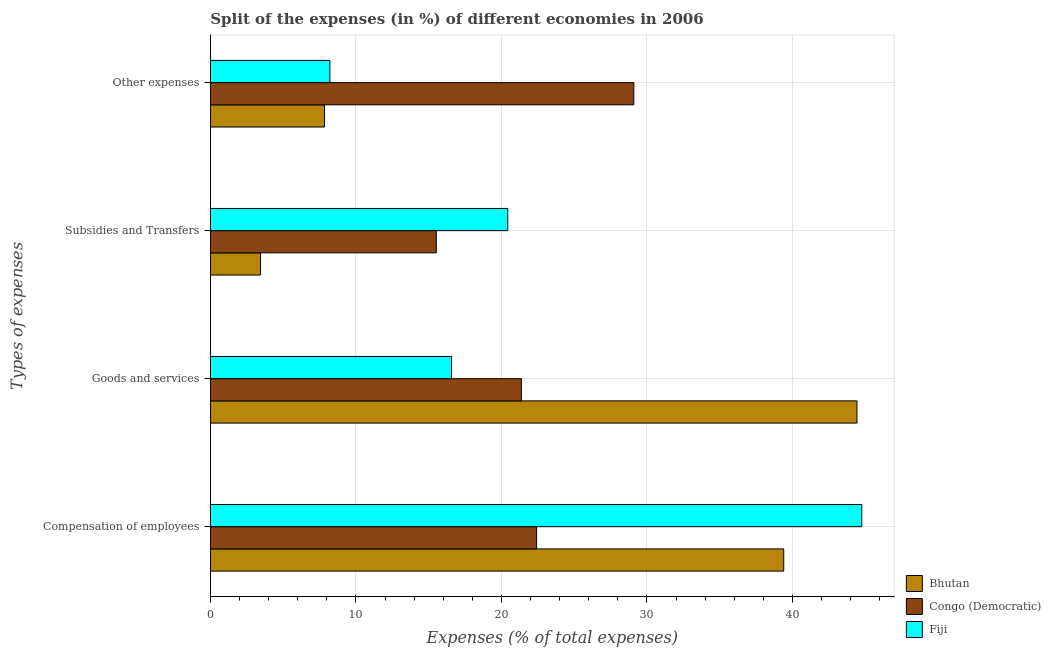Are the number of bars per tick equal to the number of legend labels?
Give a very brief answer. Yes. Are the number of bars on each tick of the Y-axis equal?
Provide a short and direct response. Yes. How many bars are there on the 1st tick from the bottom?
Your answer should be very brief. 3. What is the label of the 3rd group of bars from the top?
Your answer should be very brief. Goods and services. What is the percentage of amount spent on subsidies in Congo (Democratic)?
Provide a succinct answer. 15.53. Across all countries, what is the maximum percentage of amount spent on other expenses?
Give a very brief answer. 29.1. Across all countries, what is the minimum percentage of amount spent on goods and services?
Your answer should be very brief. 16.57. In which country was the percentage of amount spent on compensation of employees maximum?
Make the answer very short. Fiji. In which country was the percentage of amount spent on goods and services minimum?
Provide a short and direct response. Fiji. What is the total percentage of amount spent on compensation of employees in the graph?
Keep it short and to the point. 106.59. What is the difference between the percentage of amount spent on goods and services in Bhutan and that in Fiji?
Your answer should be very brief. 27.86. What is the difference between the percentage of amount spent on other expenses in Fiji and the percentage of amount spent on compensation of employees in Congo (Democratic)?
Keep it short and to the point. -14.21. What is the average percentage of amount spent on compensation of employees per country?
Offer a terse response. 35.53. What is the difference between the percentage of amount spent on compensation of employees and percentage of amount spent on goods and services in Fiji?
Your answer should be compact. 28.19. What is the ratio of the percentage of amount spent on other expenses in Bhutan to that in Congo (Democratic)?
Give a very brief answer. 0.27. What is the difference between the highest and the second highest percentage of amount spent on compensation of employees?
Your response must be concise. 5.36. What is the difference between the highest and the lowest percentage of amount spent on goods and services?
Make the answer very short. 27.86. Is the sum of the percentage of amount spent on other expenses in Bhutan and Congo (Democratic) greater than the maximum percentage of amount spent on subsidies across all countries?
Provide a succinct answer. Yes. Is it the case that in every country, the sum of the percentage of amount spent on goods and services and percentage of amount spent on subsidies is greater than the sum of percentage of amount spent on other expenses and percentage of amount spent on compensation of employees?
Your response must be concise. No. What does the 1st bar from the top in Compensation of employees represents?
Provide a succinct answer. Fiji. What does the 2nd bar from the bottom in Other expenses represents?
Offer a very short reply. Congo (Democratic). How many bars are there?
Provide a short and direct response. 12. Are all the bars in the graph horizontal?
Your answer should be compact. Yes. How many countries are there in the graph?
Give a very brief answer. 3. Does the graph contain any zero values?
Provide a short and direct response. No. Does the graph contain grids?
Provide a short and direct response. Yes. How are the legend labels stacked?
Your answer should be very brief. Vertical. What is the title of the graph?
Give a very brief answer. Split of the expenses (in %) of different economies in 2006. What is the label or title of the X-axis?
Keep it short and to the point. Expenses (% of total expenses). What is the label or title of the Y-axis?
Offer a terse response. Types of expenses. What is the Expenses (% of total expenses) in Bhutan in Compensation of employees?
Give a very brief answer. 39.4. What is the Expenses (% of total expenses) in Congo (Democratic) in Compensation of employees?
Offer a very short reply. 22.42. What is the Expenses (% of total expenses) in Fiji in Compensation of employees?
Ensure brevity in your answer.  44.77. What is the Expenses (% of total expenses) in Bhutan in Goods and services?
Offer a terse response. 44.44. What is the Expenses (% of total expenses) in Congo (Democratic) in Goods and services?
Provide a succinct answer. 21.37. What is the Expenses (% of total expenses) of Fiji in Goods and services?
Offer a terse response. 16.57. What is the Expenses (% of total expenses) of Bhutan in Subsidies and Transfers?
Provide a short and direct response. 3.45. What is the Expenses (% of total expenses) of Congo (Democratic) in Subsidies and Transfers?
Your answer should be very brief. 15.53. What is the Expenses (% of total expenses) in Fiji in Subsidies and Transfers?
Give a very brief answer. 20.44. What is the Expenses (% of total expenses) of Bhutan in Other expenses?
Your answer should be compact. 7.85. What is the Expenses (% of total expenses) in Congo (Democratic) in Other expenses?
Give a very brief answer. 29.1. What is the Expenses (% of total expenses) in Fiji in Other expenses?
Make the answer very short. 8.21. Across all Types of expenses, what is the maximum Expenses (% of total expenses) in Bhutan?
Your answer should be compact. 44.44. Across all Types of expenses, what is the maximum Expenses (% of total expenses) in Congo (Democratic)?
Make the answer very short. 29.1. Across all Types of expenses, what is the maximum Expenses (% of total expenses) of Fiji?
Ensure brevity in your answer.  44.77. Across all Types of expenses, what is the minimum Expenses (% of total expenses) of Bhutan?
Your answer should be very brief. 3.45. Across all Types of expenses, what is the minimum Expenses (% of total expenses) of Congo (Democratic)?
Make the answer very short. 15.53. Across all Types of expenses, what is the minimum Expenses (% of total expenses) in Fiji?
Provide a succinct answer. 8.21. What is the total Expenses (% of total expenses) of Bhutan in the graph?
Make the answer very short. 95.13. What is the total Expenses (% of total expenses) in Congo (Democratic) in the graph?
Your answer should be compact. 88.42. What is the total Expenses (% of total expenses) of Fiji in the graph?
Ensure brevity in your answer.  89.99. What is the difference between the Expenses (% of total expenses) in Bhutan in Compensation of employees and that in Goods and services?
Make the answer very short. -5.03. What is the difference between the Expenses (% of total expenses) of Congo (Democratic) in Compensation of employees and that in Goods and services?
Provide a succinct answer. 1.05. What is the difference between the Expenses (% of total expenses) in Fiji in Compensation of employees and that in Goods and services?
Your answer should be very brief. 28.19. What is the difference between the Expenses (% of total expenses) in Bhutan in Compensation of employees and that in Subsidies and Transfers?
Provide a short and direct response. 35.96. What is the difference between the Expenses (% of total expenses) in Congo (Democratic) in Compensation of employees and that in Subsidies and Transfers?
Your answer should be very brief. 6.89. What is the difference between the Expenses (% of total expenses) in Fiji in Compensation of employees and that in Subsidies and Transfers?
Your answer should be compact. 24.33. What is the difference between the Expenses (% of total expenses) in Bhutan in Compensation of employees and that in Other expenses?
Provide a short and direct response. 31.56. What is the difference between the Expenses (% of total expenses) of Congo (Democratic) in Compensation of employees and that in Other expenses?
Provide a succinct answer. -6.68. What is the difference between the Expenses (% of total expenses) in Fiji in Compensation of employees and that in Other expenses?
Your answer should be very brief. 36.55. What is the difference between the Expenses (% of total expenses) of Bhutan in Goods and services and that in Subsidies and Transfers?
Provide a succinct answer. 40.99. What is the difference between the Expenses (% of total expenses) of Congo (Democratic) in Goods and services and that in Subsidies and Transfers?
Offer a very short reply. 5.85. What is the difference between the Expenses (% of total expenses) in Fiji in Goods and services and that in Subsidies and Transfers?
Your answer should be compact. -3.86. What is the difference between the Expenses (% of total expenses) of Bhutan in Goods and services and that in Other expenses?
Provide a succinct answer. 36.59. What is the difference between the Expenses (% of total expenses) in Congo (Democratic) in Goods and services and that in Other expenses?
Offer a very short reply. -7.73. What is the difference between the Expenses (% of total expenses) in Fiji in Goods and services and that in Other expenses?
Your answer should be compact. 8.36. What is the difference between the Expenses (% of total expenses) of Bhutan in Subsidies and Transfers and that in Other expenses?
Give a very brief answer. -4.4. What is the difference between the Expenses (% of total expenses) of Congo (Democratic) in Subsidies and Transfers and that in Other expenses?
Offer a very short reply. -13.57. What is the difference between the Expenses (% of total expenses) of Fiji in Subsidies and Transfers and that in Other expenses?
Make the answer very short. 12.22. What is the difference between the Expenses (% of total expenses) in Bhutan in Compensation of employees and the Expenses (% of total expenses) in Congo (Democratic) in Goods and services?
Make the answer very short. 18.03. What is the difference between the Expenses (% of total expenses) of Bhutan in Compensation of employees and the Expenses (% of total expenses) of Fiji in Goods and services?
Keep it short and to the point. 22.83. What is the difference between the Expenses (% of total expenses) in Congo (Democratic) in Compensation of employees and the Expenses (% of total expenses) in Fiji in Goods and services?
Provide a succinct answer. 5.84. What is the difference between the Expenses (% of total expenses) in Bhutan in Compensation of employees and the Expenses (% of total expenses) in Congo (Democratic) in Subsidies and Transfers?
Give a very brief answer. 23.88. What is the difference between the Expenses (% of total expenses) of Bhutan in Compensation of employees and the Expenses (% of total expenses) of Fiji in Subsidies and Transfers?
Offer a terse response. 18.97. What is the difference between the Expenses (% of total expenses) in Congo (Democratic) in Compensation of employees and the Expenses (% of total expenses) in Fiji in Subsidies and Transfers?
Provide a short and direct response. 1.98. What is the difference between the Expenses (% of total expenses) of Bhutan in Compensation of employees and the Expenses (% of total expenses) of Congo (Democratic) in Other expenses?
Provide a short and direct response. 10.3. What is the difference between the Expenses (% of total expenses) of Bhutan in Compensation of employees and the Expenses (% of total expenses) of Fiji in Other expenses?
Offer a very short reply. 31.19. What is the difference between the Expenses (% of total expenses) in Congo (Democratic) in Compensation of employees and the Expenses (% of total expenses) in Fiji in Other expenses?
Your answer should be compact. 14.21. What is the difference between the Expenses (% of total expenses) of Bhutan in Goods and services and the Expenses (% of total expenses) of Congo (Democratic) in Subsidies and Transfers?
Your response must be concise. 28.91. What is the difference between the Expenses (% of total expenses) in Bhutan in Goods and services and the Expenses (% of total expenses) in Fiji in Subsidies and Transfers?
Provide a short and direct response. 24. What is the difference between the Expenses (% of total expenses) in Congo (Democratic) in Goods and services and the Expenses (% of total expenses) in Fiji in Subsidies and Transfers?
Offer a very short reply. 0.94. What is the difference between the Expenses (% of total expenses) of Bhutan in Goods and services and the Expenses (% of total expenses) of Congo (Democratic) in Other expenses?
Your answer should be compact. 15.34. What is the difference between the Expenses (% of total expenses) in Bhutan in Goods and services and the Expenses (% of total expenses) in Fiji in Other expenses?
Give a very brief answer. 36.23. What is the difference between the Expenses (% of total expenses) of Congo (Democratic) in Goods and services and the Expenses (% of total expenses) of Fiji in Other expenses?
Offer a very short reply. 13.16. What is the difference between the Expenses (% of total expenses) of Bhutan in Subsidies and Transfers and the Expenses (% of total expenses) of Congo (Democratic) in Other expenses?
Your response must be concise. -25.65. What is the difference between the Expenses (% of total expenses) of Bhutan in Subsidies and Transfers and the Expenses (% of total expenses) of Fiji in Other expenses?
Ensure brevity in your answer.  -4.76. What is the difference between the Expenses (% of total expenses) of Congo (Democratic) in Subsidies and Transfers and the Expenses (% of total expenses) of Fiji in Other expenses?
Offer a very short reply. 7.31. What is the average Expenses (% of total expenses) in Bhutan per Types of expenses?
Make the answer very short. 23.78. What is the average Expenses (% of total expenses) of Congo (Democratic) per Types of expenses?
Offer a very short reply. 22.1. What is the average Expenses (% of total expenses) of Fiji per Types of expenses?
Ensure brevity in your answer.  22.5. What is the difference between the Expenses (% of total expenses) of Bhutan and Expenses (% of total expenses) of Congo (Democratic) in Compensation of employees?
Give a very brief answer. 16.98. What is the difference between the Expenses (% of total expenses) of Bhutan and Expenses (% of total expenses) of Fiji in Compensation of employees?
Your answer should be very brief. -5.36. What is the difference between the Expenses (% of total expenses) in Congo (Democratic) and Expenses (% of total expenses) in Fiji in Compensation of employees?
Your response must be concise. -22.35. What is the difference between the Expenses (% of total expenses) in Bhutan and Expenses (% of total expenses) in Congo (Democratic) in Goods and services?
Give a very brief answer. 23.06. What is the difference between the Expenses (% of total expenses) in Bhutan and Expenses (% of total expenses) in Fiji in Goods and services?
Offer a terse response. 27.86. What is the difference between the Expenses (% of total expenses) in Congo (Democratic) and Expenses (% of total expenses) in Fiji in Goods and services?
Your answer should be very brief. 4.8. What is the difference between the Expenses (% of total expenses) of Bhutan and Expenses (% of total expenses) of Congo (Democratic) in Subsidies and Transfers?
Offer a very short reply. -12.08. What is the difference between the Expenses (% of total expenses) in Bhutan and Expenses (% of total expenses) in Fiji in Subsidies and Transfers?
Provide a short and direct response. -16.99. What is the difference between the Expenses (% of total expenses) in Congo (Democratic) and Expenses (% of total expenses) in Fiji in Subsidies and Transfers?
Your answer should be compact. -4.91. What is the difference between the Expenses (% of total expenses) of Bhutan and Expenses (% of total expenses) of Congo (Democratic) in Other expenses?
Ensure brevity in your answer.  -21.25. What is the difference between the Expenses (% of total expenses) in Bhutan and Expenses (% of total expenses) in Fiji in Other expenses?
Give a very brief answer. -0.36. What is the difference between the Expenses (% of total expenses) of Congo (Democratic) and Expenses (% of total expenses) of Fiji in Other expenses?
Your answer should be very brief. 20.89. What is the ratio of the Expenses (% of total expenses) of Bhutan in Compensation of employees to that in Goods and services?
Keep it short and to the point. 0.89. What is the ratio of the Expenses (% of total expenses) of Congo (Democratic) in Compensation of employees to that in Goods and services?
Your answer should be compact. 1.05. What is the ratio of the Expenses (% of total expenses) of Fiji in Compensation of employees to that in Goods and services?
Keep it short and to the point. 2.7. What is the ratio of the Expenses (% of total expenses) in Bhutan in Compensation of employees to that in Subsidies and Transfers?
Make the answer very short. 11.43. What is the ratio of the Expenses (% of total expenses) in Congo (Democratic) in Compensation of employees to that in Subsidies and Transfers?
Provide a succinct answer. 1.44. What is the ratio of the Expenses (% of total expenses) of Fiji in Compensation of employees to that in Subsidies and Transfers?
Your answer should be compact. 2.19. What is the ratio of the Expenses (% of total expenses) in Bhutan in Compensation of employees to that in Other expenses?
Keep it short and to the point. 5.02. What is the ratio of the Expenses (% of total expenses) in Congo (Democratic) in Compensation of employees to that in Other expenses?
Your response must be concise. 0.77. What is the ratio of the Expenses (% of total expenses) of Fiji in Compensation of employees to that in Other expenses?
Offer a very short reply. 5.45. What is the ratio of the Expenses (% of total expenses) of Bhutan in Goods and services to that in Subsidies and Transfers?
Keep it short and to the point. 12.89. What is the ratio of the Expenses (% of total expenses) in Congo (Democratic) in Goods and services to that in Subsidies and Transfers?
Provide a succinct answer. 1.38. What is the ratio of the Expenses (% of total expenses) of Fiji in Goods and services to that in Subsidies and Transfers?
Make the answer very short. 0.81. What is the ratio of the Expenses (% of total expenses) of Bhutan in Goods and services to that in Other expenses?
Your answer should be very brief. 5.66. What is the ratio of the Expenses (% of total expenses) in Congo (Democratic) in Goods and services to that in Other expenses?
Make the answer very short. 0.73. What is the ratio of the Expenses (% of total expenses) in Fiji in Goods and services to that in Other expenses?
Keep it short and to the point. 2.02. What is the ratio of the Expenses (% of total expenses) of Bhutan in Subsidies and Transfers to that in Other expenses?
Your answer should be compact. 0.44. What is the ratio of the Expenses (% of total expenses) in Congo (Democratic) in Subsidies and Transfers to that in Other expenses?
Make the answer very short. 0.53. What is the ratio of the Expenses (% of total expenses) in Fiji in Subsidies and Transfers to that in Other expenses?
Provide a short and direct response. 2.49. What is the difference between the highest and the second highest Expenses (% of total expenses) of Bhutan?
Make the answer very short. 5.03. What is the difference between the highest and the second highest Expenses (% of total expenses) of Congo (Democratic)?
Your response must be concise. 6.68. What is the difference between the highest and the second highest Expenses (% of total expenses) in Fiji?
Offer a terse response. 24.33. What is the difference between the highest and the lowest Expenses (% of total expenses) of Bhutan?
Offer a terse response. 40.99. What is the difference between the highest and the lowest Expenses (% of total expenses) of Congo (Democratic)?
Your response must be concise. 13.57. What is the difference between the highest and the lowest Expenses (% of total expenses) in Fiji?
Offer a very short reply. 36.55. 